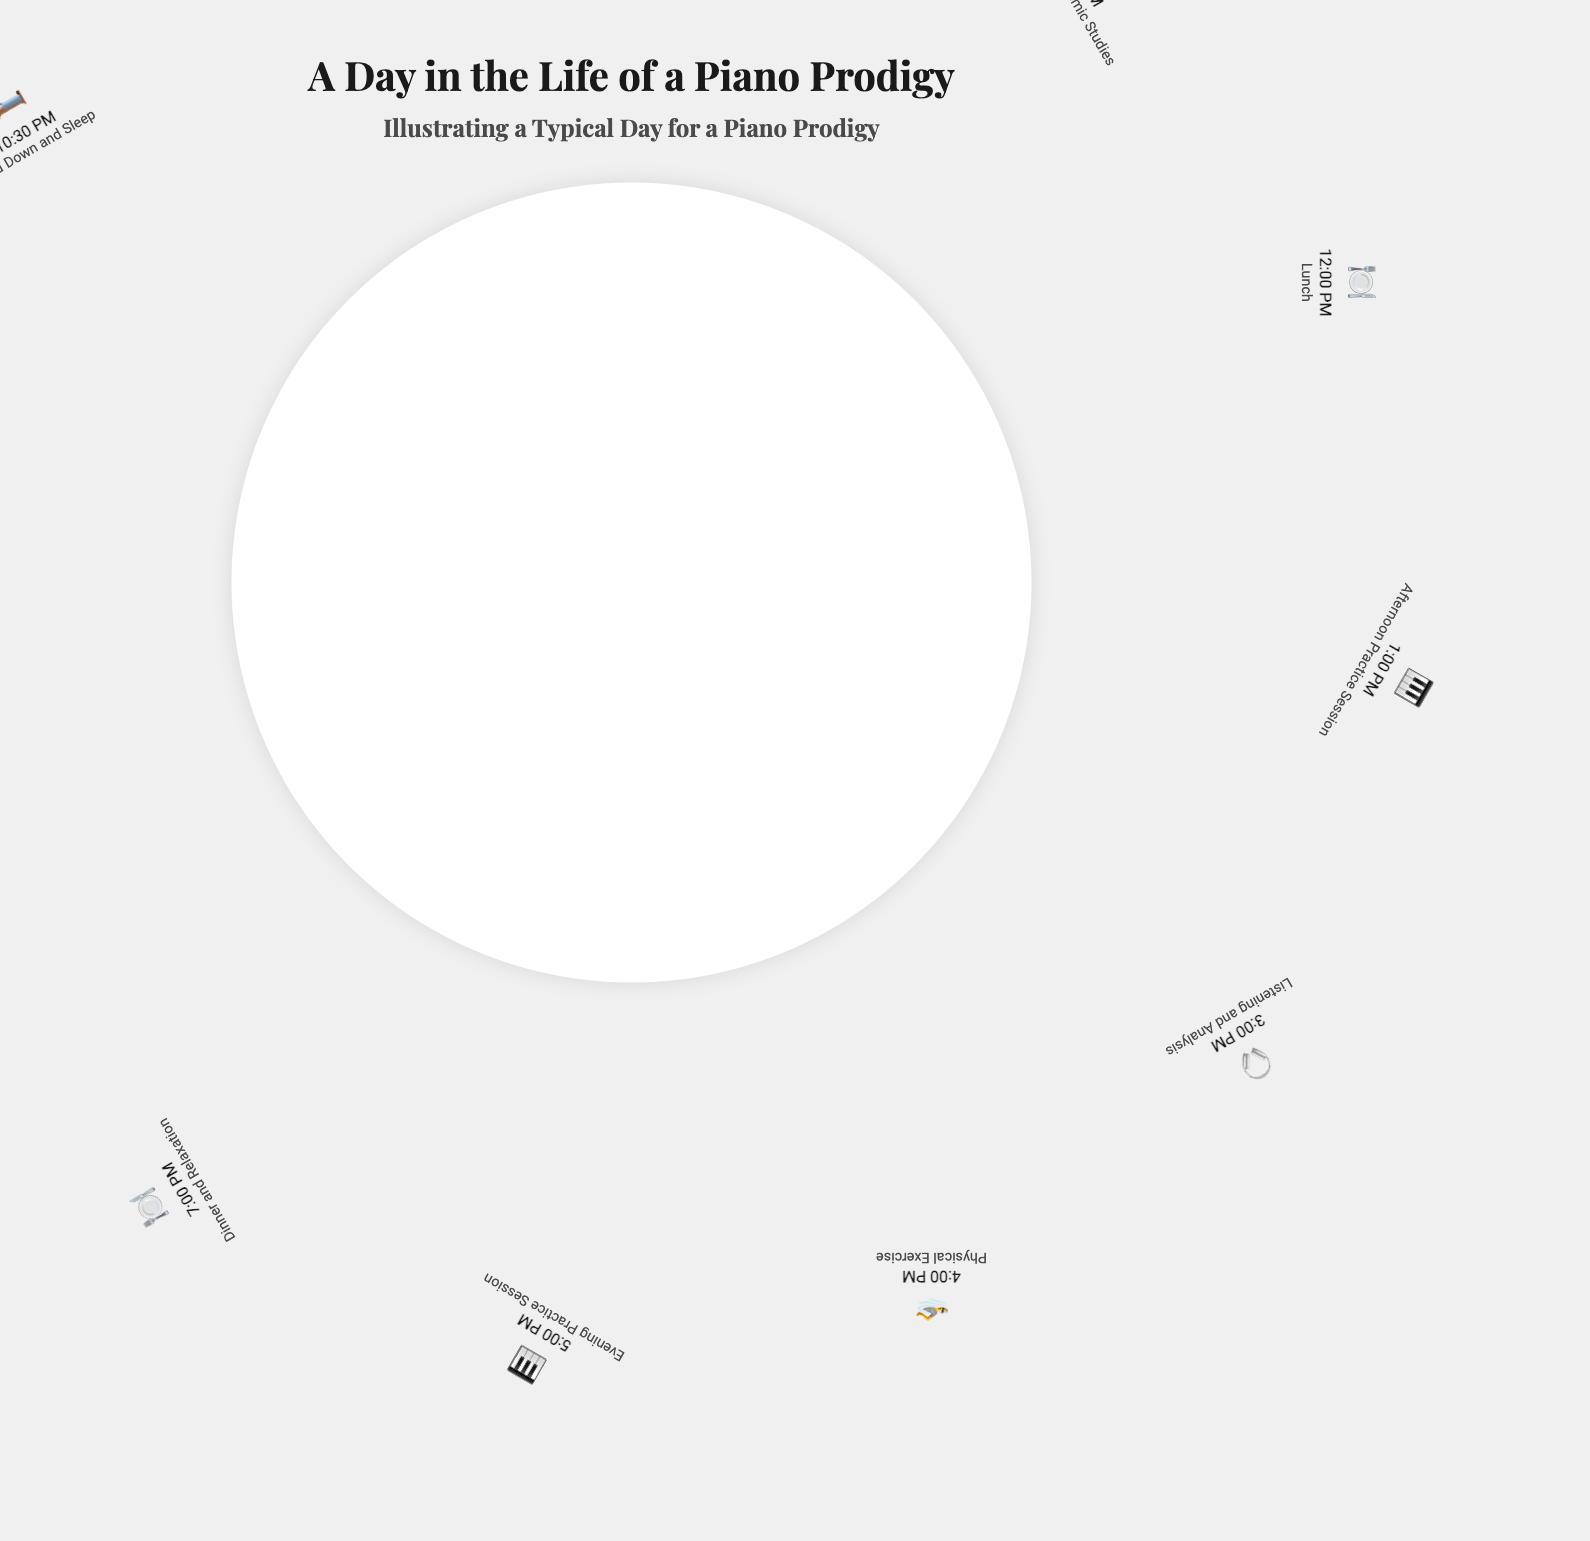what time does the piano prodigy wake up? The document indicates that the piano prodigy wakes up at 7:00 AM.
Answer: 7:00 AM how many practice sessions are there throughout the day? The document lists three practice sessions: morning, afternoon, and evening.
Answer: 3 what is the activity at 3:00 PM? At 3:00 PM, the activity is listening and analysis.
Answer: Listening and Analysis what meal is scheduled at 12:00 PM? The document states that lunch is scheduled at 12:00 PM.
Answer: Lunch which physical activity is mentioned at 4:00 PM? The document specifies that physical exercise can include swimming or yoga at 4:00 PM.
Answer: Swimming or yoga why is reviewing planned for 10:00 PM? The review is planned to assess the day's achievements and challenges and to set the next day's practice schedule.
Answer: To assess achievements and set next day's schedule what is depicted as the first activity of the day? The first activity is waking up and the morning routine at 7:00 AM.
Answer: Wake Up and Morning Routine how does the piano prodigy wind down for the night? The day ends with a wind-down routine and sleep at 10:30 PM.
Answer: Wind Down and Sleep who is mentioned as a source of inspiration during listening and analysis? The document refers to famous pianists like Lang Lang or Martha Argerich as inspirations.
Answer: Lang Lang or Martha Argerich 